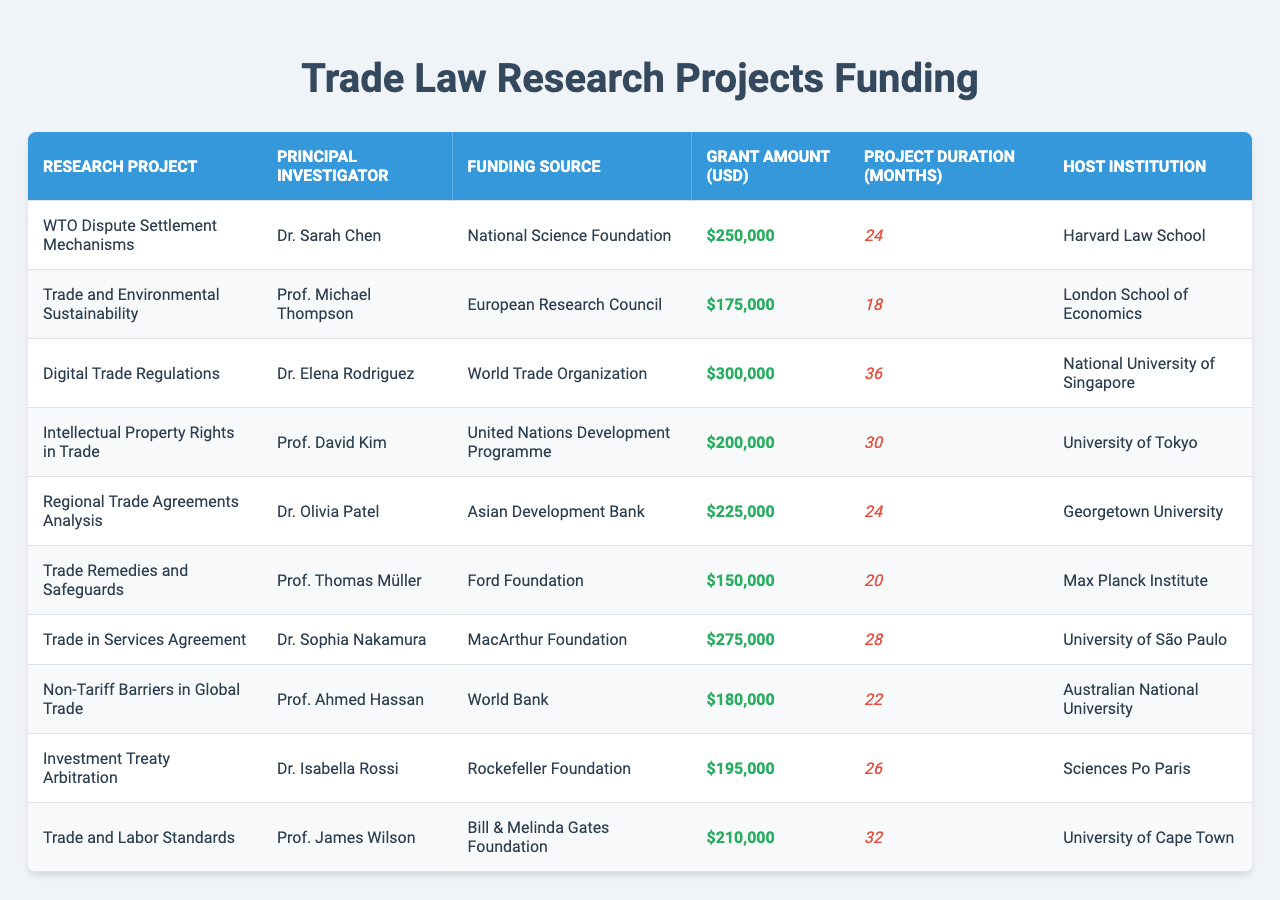What is the funding source for the project "Trade and Environmental Sustainability"? By locating "Trade and Environmental Sustainability" in the table, we check its corresponding funding source, which is the "European Research Council".
Answer: European Research Council Who is the principal investigator for the project with the highest grant amount? The project with the highest grant amount is "Digital Trade Regulations," which has a grant of $300,000. The principal investigator for this project is Dr. Elena Rodriguez.
Answer: Dr. Elena Rodriguez What is the total grant amount for all projects combined? Summing all the grant amounts: 250000 + 175000 + 300000 + 200000 + 225000 + 150000 + 275000 + 180000 + 195000 + 210000 equals 1,760,000.
Answer: 1,760,000 Which host institution has the longest project duration? Analyzing the project durations, "Intellectual Property Rights in Trade" has the longest duration of 36 months. The host institution for this project is the University of Tokyo.
Answer: University of Tokyo Is the funding source for "Non-Tariff Barriers in Global Trade" the World Bank? Checking the funding source listed for "Non-Tariff Barriers in Global Trade," we can see it is the "World Bank," so the answer is yes.
Answer: Yes What is the average project duration for all research projects? The project durations are summed (24 + 18 + 36 + 30 + 24 + 20 + 28 + 22 + 26 + 32 =  240). Dividing by the number of projects (10), we get an average duration of 24 months.
Answer: 24 months Which project has the second-highest grant amount, and who is its principal investigator? The second-highest grant amount is $275,000 for the project "Trade in Services Agreement." The principal investigator for this project is Dr. Sophia Nakamura.
Answer: Trade in Services Agreement, Dr. Sophia Nakamura How many projects received funding from the Bill & Melinda Gates Foundation? Checking the funding source in the table, we see that only one project, "Trade and Labor Standards," received funding from the Bill & Melinda Gates Foundation.
Answer: 1 What is the difference in grant amounts between the projects "WTO Dispute Settlement Mechanisms" and "Ford Foundation"? The grant amount for "WTO Dispute Settlement Mechanisms" is $250,000, while the grant for "Trade Remedies and Safeguards" funded by the Ford Foundation is $150,000. The difference is $250,000 - $150,000 = $100,000.
Answer: $100,000 Which principal investigator is associated with the lowest grant amount? Checking the grant amounts, "Trade Remedies and Safeguards" has the lowest grant of $150,000. The principal investigator associated with this project is Prof. Thomas Müller.
Answer: Prof. Thomas Müller 